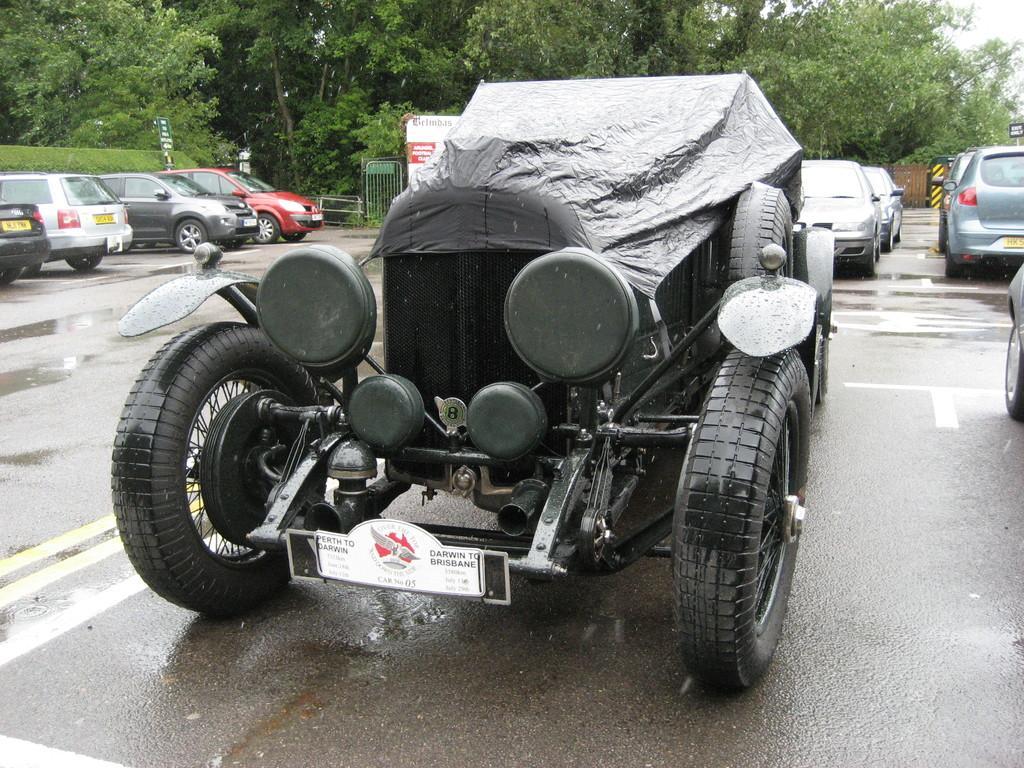Please provide a concise description of this image. In front of the image there is a jeep with a cover. Behind the jeep on the road there are many cars. And also there are poles with sign boards and there is fencing. In the background there are many trees. 